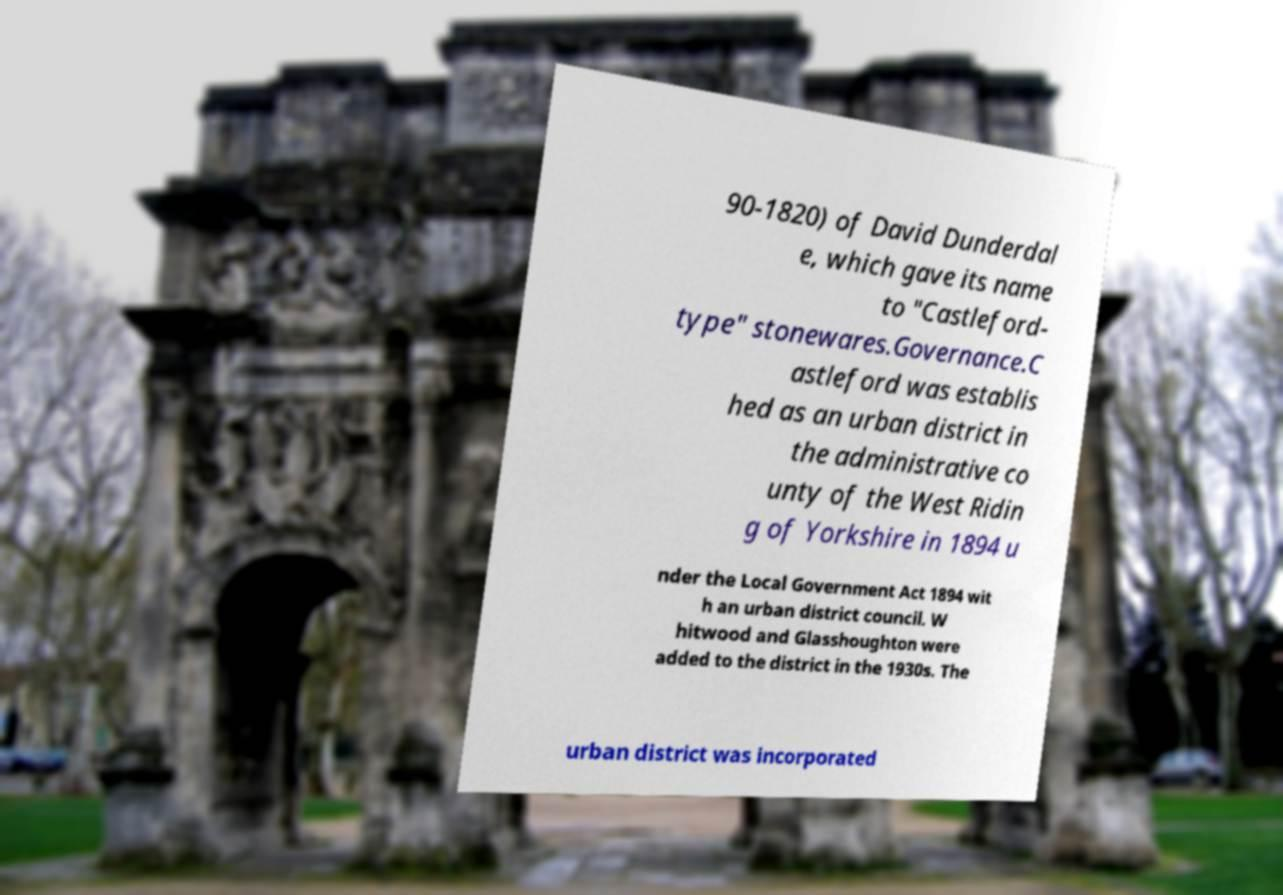I need the written content from this picture converted into text. Can you do that? 90-1820) of David Dunderdal e, which gave its name to "Castleford- type" stonewares.Governance.C astleford was establis hed as an urban district in the administrative co unty of the West Ridin g of Yorkshire in 1894 u nder the Local Government Act 1894 wit h an urban district council. W hitwood and Glasshoughton were added to the district in the 1930s. The urban district was incorporated 